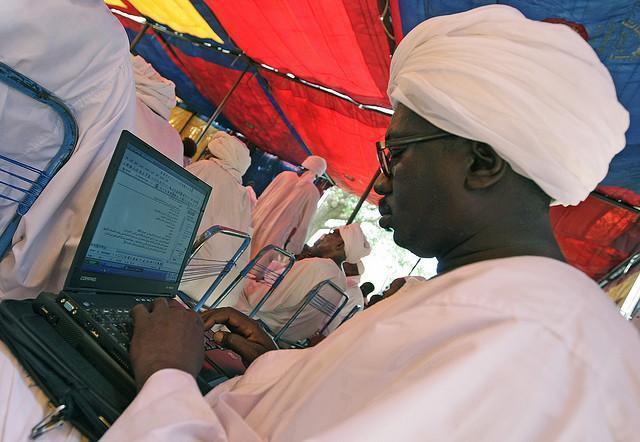How many people are visible?
Give a very brief answer. 6. How many laptops are in the photo?
Give a very brief answer. 1. 